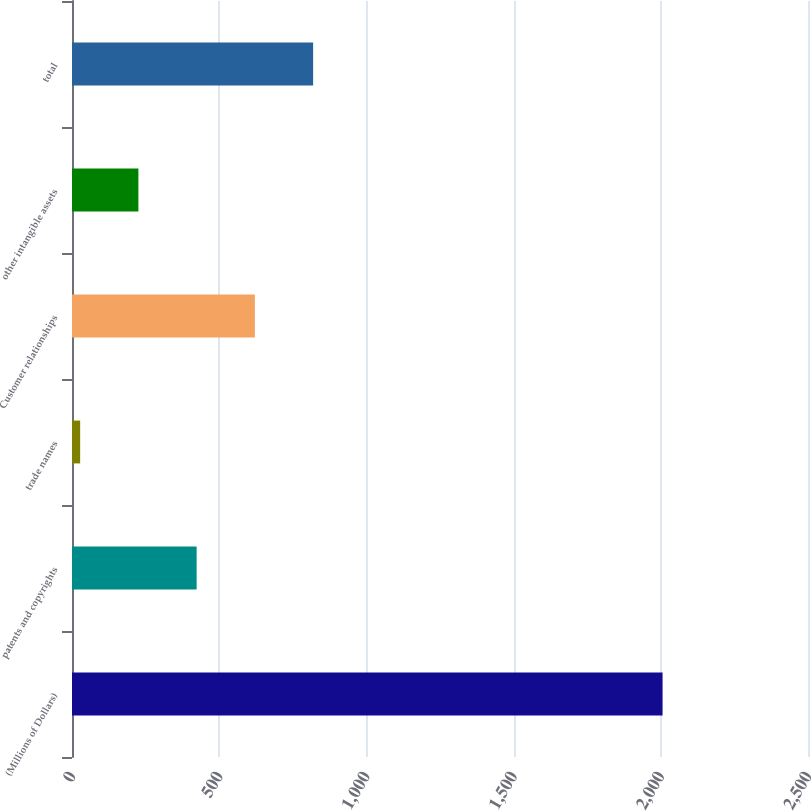Convert chart. <chart><loc_0><loc_0><loc_500><loc_500><bar_chart><fcel>(Millions of Dollars)<fcel>patents and copyrights<fcel>trade names<fcel>Customer relationships<fcel>other intangible assets<fcel>total<nl><fcel>2006<fcel>423.36<fcel>27.7<fcel>621.19<fcel>225.53<fcel>819.02<nl></chart> 